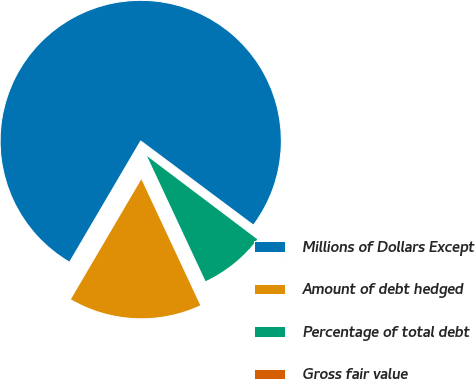<chart> <loc_0><loc_0><loc_500><loc_500><pie_chart><fcel>Millions of Dollars Except<fcel>Amount of debt hedged<fcel>Percentage of total debt<fcel>Gross fair value<nl><fcel>76.76%<fcel>15.41%<fcel>7.75%<fcel>0.08%<nl></chart> 